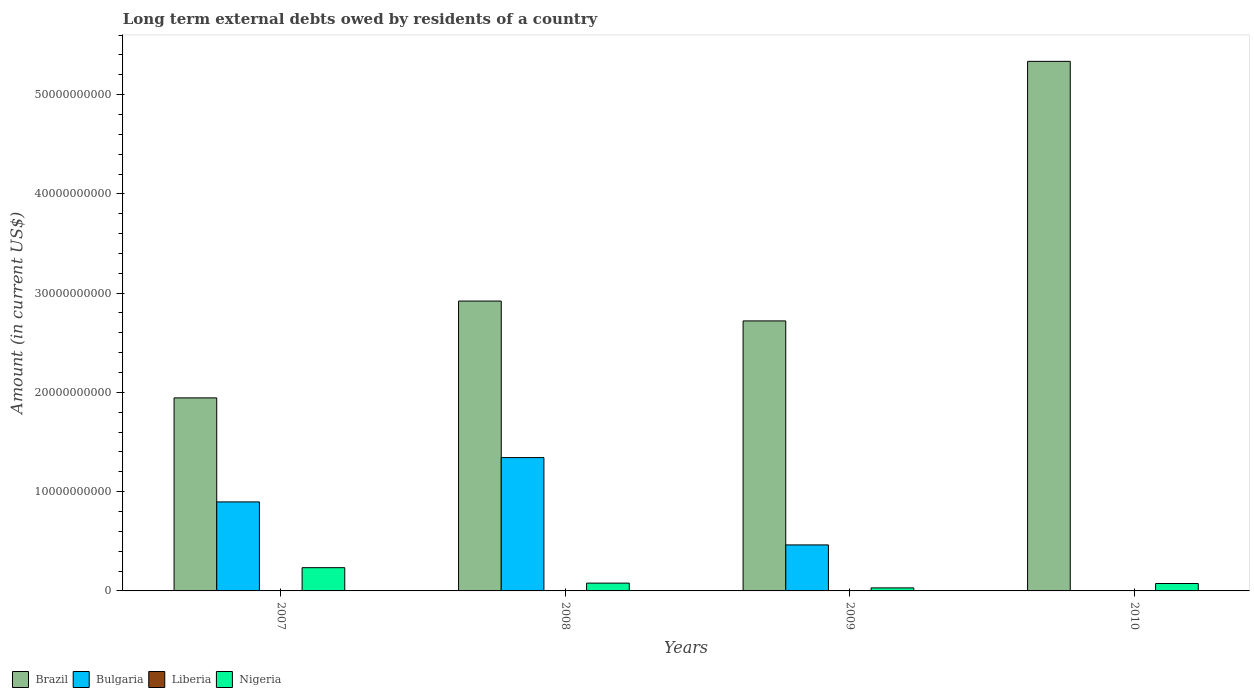Are the number of bars on each tick of the X-axis equal?
Make the answer very short. No. How many bars are there on the 4th tick from the left?
Your answer should be very brief. 2. In how many cases, is the number of bars for a given year not equal to the number of legend labels?
Your answer should be very brief. 4. What is the amount of long-term external debts owed by residents in Brazil in 2008?
Your response must be concise. 2.92e+1. Across all years, what is the maximum amount of long-term external debts owed by residents in Brazil?
Your response must be concise. 5.34e+1. Across all years, what is the minimum amount of long-term external debts owed by residents in Nigeria?
Keep it short and to the point. 3.05e+08. What is the total amount of long-term external debts owed by residents in Brazil in the graph?
Provide a short and direct response. 1.29e+11. What is the difference between the amount of long-term external debts owed by residents in Nigeria in 2008 and that in 2010?
Offer a terse response. 3.94e+07. What is the difference between the amount of long-term external debts owed by residents in Liberia in 2008 and the amount of long-term external debts owed by residents in Nigeria in 2009?
Ensure brevity in your answer.  -3.05e+08. What is the average amount of long-term external debts owed by residents in Nigeria per year?
Provide a short and direct response. 1.04e+09. In the year 2008, what is the difference between the amount of long-term external debts owed by residents in Bulgaria and amount of long-term external debts owed by residents in Nigeria?
Give a very brief answer. 1.26e+1. What is the ratio of the amount of long-term external debts owed by residents in Brazil in 2007 to that in 2008?
Offer a terse response. 0.67. Is the difference between the amount of long-term external debts owed by residents in Bulgaria in 2008 and 2009 greater than the difference between the amount of long-term external debts owed by residents in Nigeria in 2008 and 2009?
Give a very brief answer. Yes. What is the difference between the highest and the second highest amount of long-term external debts owed by residents in Nigeria?
Keep it short and to the point. 1.56e+09. What is the difference between the highest and the lowest amount of long-term external debts owed by residents in Bulgaria?
Give a very brief answer. 1.34e+1. How many bars are there?
Give a very brief answer. 11. Are all the bars in the graph horizontal?
Keep it short and to the point. No. How many years are there in the graph?
Your answer should be very brief. 4. What is the difference between two consecutive major ticks on the Y-axis?
Keep it short and to the point. 1.00e+1. Are the values on the major ticks of Y-axis written in scientific E-notation?
Provide a succinct answer. No. Does the graph contain any zero values?
Your response must be concise. Yes. Does the graph contain grids?
Give a very brief answer. No. Where does the legend appear in the graph?
Make the answer very short. Bottom left. What is the title of the graph?
Ensure brevity in your answer.  Long term external debts owed by residents of a country. Does "Fragile and conflict affected situations" appear as one of the legend labels in the graph?
Provide a short and direct response. No. What is the label or title of the X-axis?
Keep it short and to the point. Years. What is the label or title of the Y-axis?
Keep it short and to the point. Amount (in current US$). What is the Amount (in current US$) in Brazil in 2007?
Your answer should be compact. 1.94e+1. What is the Amount (in current US$) of Bulgaria in 2007?
Your answer should be compact. 8.97e+09. What is the Amount (in current US$) of Liberia in 2007?
Offer a terse response. 0. What is the Amount (in current US$) in Nigeria in 2007?
Offer a terse response. 2.34e+09. What is the Amount (in current US$) in Brazil in 2008?
Provide a succinct answer. 2.92e+1. What is the Amount (in current US$) in Bulgaria in 2008?
Offer a very short reply. 1.34e+1. What is the Amount (in current US$) of Liberia in 2008?
Offer a very short reply. 0. What is the Amount (in current US$) in Nigeria in 2008?
Your response must be concise. 7.86e+08. What is the Amount (in current US$) in Brazil in 2009?
Provide a short and direct response. 2.72e+1. What is the Amount (in current US$) of Bulgaria in 2009?
Keep it short and to the point. 4.64e+09. What is the Amount (in current US$) of Liberia in 2009?
Make the answer very short. 0. What is the Amount (in current US$) in Nigeria in 2009?
Your answer should be compact. 3.05e+08. What is the Amount (in current US$) in Brazil in 2010?
Give a very brief answer. 5.34e+1. What is the Amount (in current US$) of Bulgaria in 2010?
Offer a very short reply. 0. What is the Amount (in current US$) of Nigeria in 2010?
Offer a terse response. 7.46e+08. Across all years, what is the maximum Amount (in current US$) of Brazil?
Your answer should be very brief. 5.34e+1. Across all years, what is the maximum Amount (in current US$) of Bulgaria?
Your answer should be very brief. 1.34e+1. Across all years, what is the maximum Amount (in current US$) in Nigeria?
Give a very brief answer. 2.34e+09. Across all years, what is the minimum Amount (in current US$) of Brazil?
Provide a short and direct response. 1.94e+1. Across all years, what is the minimum Amount (in current US$) of Nigeria?
Keep it short and to the point. 3.05e+08. What is the total Amount (in current US$) in Brazil in the graph?
Provide a short and direct response. 1.29e+11. What is the total Amount (in current US$) in Bulgaria in the graph?
Give a very brief answer. 2.70e+1. What is the total Amount (in current US$) in Liberia in the graph?
Give a very brief answer. 0. What is the total Amount (in current US$) in Nigeria in the graph?
Your answer should be compact. 4.18e+09. What is the difference between the Amount (in current US$) of Brazil in 2007 and that in 2008?
Provide a succinct answer. -9.76e+09. What is the difference between the Amount (in current US$) of Bulgaria in 2007 and that in 2008?
Your answer should be compact. -4.47e+09. What is the difference between the Amount (in current US$) in Nigeria in 2007 and that in 2008?
Your answer should be compact. 1.56e+09. What is the difference between the Amount (in current US$) of Brazil in 2007 and that in 2009?
Keep it short and to the point. -7.75e+09. What is the difference between the Amount (in current US$) in Bulgaria in 2007 and that in 2009?
Offer a very short reply. 4.33e+09. What is the difference between the Amount (in current US$) of Nigeria in 2007 and that in 2009?
Your response must be concise. 2.04e+09. What is the difference between the Amount (in current US$) in Brazil in 2007 and that in 2010?
Your answer should be very brief. -3.39e+1. What is the difference between the Amount (in current US$) of Nigeria in 2007 and that in 2010?
Ensure brevity in your answer.  1.60e+09. What is the difference between the Amount (in current US$) in Brazil in 2008 and that in 2009?
Your answer should be compact. 2.00e+09. What is the difference between the Amount (in current US$) of Bulgaria in 2008 and that in 2009?
Make the answer very short. 8.80e+09. What is the difference between the Amount (in current US$) in Nigeria in 2008 and that in 2009?
Offer a very short reply. 4.80e+08. What is the difference between the Amount (in current US$) in Brazil in 2008 and that in 2010?
Make the answer very short. -2.41e+1. What is the difference between the Amount (in current US$) in Nigeria in 2008 and that in 2010?
Your answer should be very brief. 3.94e+07. What is the difference between the Amount (in current US$) in Brazil in 2009 and that in 2010?
Provide a succinct answer. -2.61e+1. What is the difference between the Amount (in current US$) in Nigeria in 2009 and that in 2010?
Provide a succinct answer. -4.41e+08. What is the difference between the Amount (in current US$) of Brazil in 2007 and the Amount (in current US$) of Bulgaria in 2008?
Provide a succinct answer. 6.02e+09. What is the difference between the Amount (in current US$) in Brazil in 2007 and the Amount (in current US$) in Nigeria in 2008?
Make the answer very short. 1.87e+1. What is the difference between the Amount (in current US$) in Bulgaria in 2007 and the Amount (in current US$) in Nigeria in 2008?
Keep it short and to the point. 8.18e+09. What is the difference between the Amount (in current US$) in Brazil in 2007 and the Amount (in current US$) in Bulgaria in 2009?
Provide a short and direct response. 1.48e+1. What is the difference between the Amount (in current US$) in Brazil in 2007 and the Amount (in current US$) in Nigeria in 2009?
Your answer should be very brief. 1.91e+1. What is the difference between the Amount (in current US$) of Bulgaria in 2007 and the Amount (in current US$) of Nigeria in 2009?
Your answer should be very brief. 8.66e+09. What is the difference between the Amount (in current US$) of Brazil in 2007 and the Amount (in current US$) of Nigeria in 2010?
Make the answer very short. 1.87e+1. What is the difference between the Amount (in current US$) of Bulgaria in 2007 and the Amount (in current US$) of Nigeria in 2010?
Your answer should be very brief. 8.22e+09. What is the difference between the Amount (in current US$) of Brazil in 2008 and the Amount (in current US$) of Bulgaria in 2009?
Give a very brief answer. 2.46e+1. What is the difference between the Amount (in current US$) in Brazil in 2008 and the Amount (in current US$) in Nigeria in 2009?
Give a very brief answer. 2.89e+1. What is the difference between the Amount (in current US$) in Bulgaria in 2008 and the Amount (in current US$) in Nigeria in 2009?
Provide a succinct answer. 1.31e+1. What is the difference between the Amount (in current US$) of Brazil in 2008 and the Amount (in current US$) of Nigeria in 2010?
Offer a very short reply. 2.85e+1. What is the difference between the Amount (in current US$) in Bulgaria in 2008 and the Amount (in current US$) in Nigeria in 2010?
Give a very brief answer. 1.27e+1. What is the difference between the Amount (in current US$) of Brazil in 2009 and the Amount (in current US$) of Nigeria in 2010?
Your answer should be compact. 2.65e+1. What is the difference between the Amount (in current US$) in Bulgaria in 2009 and the Amount (in current US$) in Nigeria in 2010?
Your response must be concise. 3.89e+09. What is the average Amount (in current US$) of Brazil per year?
Provide a short and direct response. 3.23e+1. What is the average Amount (in current US$) of Bulgaria per year?
Ensure brevity in your answer.  6.76e+09. What is the average Amount (in current US$) in Liberia per year?
Provide a short and direct response. 0. What is the average Amount (in current US$) in Nigeria per year?
Your answer should be very brief. 1.04e+09. In the year 2007, what is the difference between the Amount (in current US$) in Brazil and Amount (in current US$) in Bulgaria?
Keep it short and to the point. 1.05e+1. In the year 2007, what is the difference between the Amount (in current US$) in Brazil and Amount (in current US$) in Nigeria?
Your response must be concise. 1.71e+1. In the year 2007, what is the difference between the Amount (in current US$) in Bulgaria and Amount (in current US$) in Nigeria?
Your answer should be very brief. 6.62e+09. In the year 2008, what is the difference between the Amount (in current US$) of Brazil and Amount (in current US$) of Bulgaria?
Your response must be concise. 1.58e+1. In the year 2008, what is the difference between the Amount (in current US$) of Brazil and Amount (in current US$) of Nigeria?
Give a very brief answer. 2.84e+1. In the year 2008, what is the difference between the Amount (in current US$) in Bulgaria and Amount (in current US$) in Nigeria?
Your answer should be very brief. 1.26e+1. In the year 2009, what is the difference between the Amount (in current US$) of Brazil and Amount (in current US$) of Bulgaria?
Keep it short and to the point. 2.26e+1. In the year 2009, what is the difference between the Amount (in current US$) in Brazil and Amount (in current US$) in Nigeria?
Your answer should be very brief. 2.69e+1. In the year 2009, what is the difference between the Amount (in current US$) in Bulgaria and Amount (in current US$) in Nigeria?
Your response must be concise. 4.33e+09. In the year 2010, what is the difference between the Amount (in current US$) in Brazil and Amount (in current US$) in Nigeria?
Your answer should be very brief. 5.26e+1. What is the ratio of the Amount (in current US$) of Brazil in 2007 to that in 2008?
Your response must be concise. 0.67. What is the ratio of the Amount (in current US$) in Bulgaria in 2007 to that in 2008?
Your answer should be very brief. 0.67. What is the ratio of the Amount (in current US$) of Nigeria in 2007 to that in 2008?
Your answer should be very brief. 2.98. What is the ratio of the Amount (in current US$) in Brazil in 2007 to that in 2009?
Offer a terse response. 0.71. What is the ratio of the Amount (in current US$) in Bulgaria in 2007 to that in 2009?
Give a very brief answer. 1.93. What is the ratio of the Amount (in current US$) in Nigeria in 2007 to that in 2009?
Your answer should be compact. 7.67. What is the ratio of the Amount (in current US$) of Brazil in 2007 to that in 2010?
Give a very brief answer. 0.36. What is the ratio of the Amount (in current US$) of Nigeria in 2007 to that in 2010?
Give a very brief answer. 3.14. What is the ratio of the Amount (in current US$) in Brazil in 2008 to that in 2009?
Your response must be concise. 1.07. What is the ratio of the Amount (in current US$) in Bulgaria in 2008 to that in 2009?
Offer a very short reply. 2.9. What is the ratio of the Amount (in current US$) in Nigeria in 2008 to that in 2009?
Your answer should be compact. 2.57. What is the ratio of the Amount (in current US$) in Brazil in 2008 to that in 2010?
Give a very brief answer. 0.55. What is the ratio of the Amount (in current US$) in Nigeria in 2008 to that in 2010?
Offer a very short reply. 1.05. What is the ratio of the Amount (in current US$) of Brazil in 2009 to that in 2010?
Your response must be concise. 0.51. What is the ratio of the Amount (in current US$) in Nigeria in 2009 to that in 2010?
Make the answer very short. 0.41. What is the difference between the highest and the second highest Amount (in current US$) in Brazil?
Ensure brevity in your answer.  2.41e+1. What is the difference between the highest and the second highest Amount (in current US$) in Bulgaria?
Your answer should be very brief. 4.47e+09. What is the difference between the highest and the second highest Amount (in current US$) in Nigeria?
Ensure brevity in your answer.  1.56e+09. What is the difference between the highest and the lowest Amount (in current US$) in Brazil?
Give a very brief answer. 3.39e+1. What is the difference between the highest and the lowest Amount (in current US$) in Bulgaria?
Your answer should be compact. 1.34e+1. What is the difference between the highest and the lowest Amount (in current US$) of Nigeria?
Offer a very short reply. 2.04e+09. 